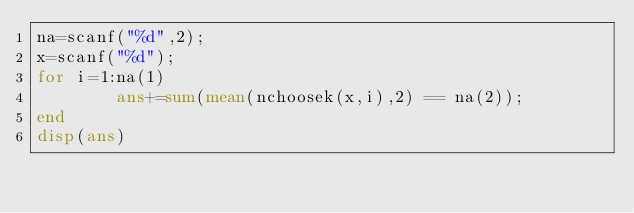<code> <loc_0><loc_0><loc_500><loc_500><_Octave_>na=scanf("%d",2);
x=scanf("%d");
for i=1:na(1)
        ans+=sum(mean(nchoosek(x,i),2) == na(2));
end
disp(ans)</code> 